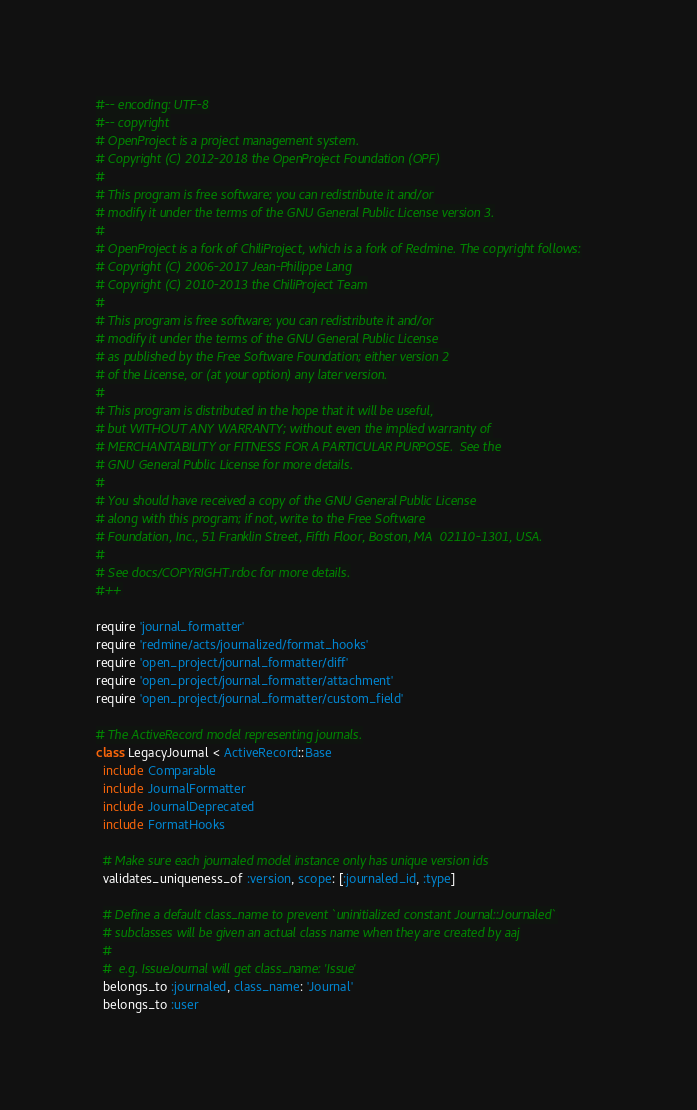<code> <loc_0><loc_0><loc_500><loc_500><_Ruby_>#-- encoding: UTF-8
#-- copyright
# OpenProject is a project management system.
# Copyright (C) 2012-2018 the OpenProject Foundation (OPF)
#
# This program is free software; you can redistribute it and/or
# modify it under the terms of the GNU General Public License version 3.
#
# OpenProject is a fork of ChiliProject, which is a fork of Redmine. The copyright follows:
# Copyright (C) 2006-2017 Jean-Philippe Lang
# Copyright (C) 2010-2013 the ChiliProject Team
#
# This program is free software; you can redistribute it and/or
# modify it under the terms of the GNU General Public License
# as published by the Free Software Foundation; either version 2
# of the License, or (at your option) any later version.
#
# This program is distributed in the hope that it will be useful,
# but WITHOUT ANY WARRANTY; without even the implied warranty of
# MERCHANTABILITY or FITNESS FOR A PARTICULAR PURPOSE.  See the
# GNU General Public License for more details.
#
# You should have received a copy of the GNU General Public License
# along with this program; if not, write to the Free Software
# Foundation, Inc., 51 Franklin Street, Fifth Floor, Boston, MA  02110-1301, USA.
#
# See docs/COPYRIGHT.rdoc for more details.
#++

require 'journal_formatter'
require 'redmine/acts/journalized/format_hooks'
require 'open_project/journal_formatter/diff'
require 'open_project/journal_formatter/attachment'
require 'open_project/journal_formatter/custom_field'

# The ActiveRecord model representing journals.
class LegacyJournal < ActiveRecord::Base
  include Comparable
  include JournalFormatter
  include JournalDeprecated
  include FormatHooks

  # Make sure each journaled model instance only has unique version ids
  validates_uniqueness_of :version, scope: [:journaled_id, :type]

  # Define a default class_name to prevent `uninitialized constant Journal::Journaled`
  # subclasses will be given an actual class name when they are created by aaj
  #
  #  e.g. IssueJournal will get class_name: 'Issue'
  belongs_to :journaled, class_name: 'Journal'
  belongs_to :user
</code> 